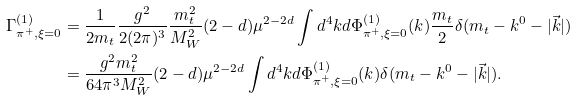<formula> <loc_0><loc_0><loc_500><loc_500>\Gamma _ { \pi ^ { + } , \xi = 0 } ^ { ( 1 ) } & = \frac { 1 } { 2 m _ { t } } \frac { g ^ { 2 } } { 2 ( 2 \pi ) ^ { 3 } } \frac { m _ { t } ^ { 2 } } { M _ { W } ^ { 2 } } ( 2 - d ) \mu ^ { 2 - 2 d } \int d ^ { 4 } k d \Phi ^ { ( 1 ) } _ { \pi ^ { + } , \xi = 0 } ( k ) \frac { m _ { t } } { 2 } \delta ( m _ { t } - k ^ { 0 } - | \vec { k } | ) \\ & = \frac { g ^ { 2 } m _ { t } ^ { 2 } } { 6 4 \pi ^ { 3 } M _ { W } ^ { 2 } } ( 2 - d ) \mu ^ { 2 - 2 d } \int d ^ { 4 } k d \Phi ^ { ( 1 ) } _ { \pi ^ { + } , \xi = 0 } ( k ) \delta ( m _ { t } - k ^ { 0 } - | \vec { k } | ) .</formula> 